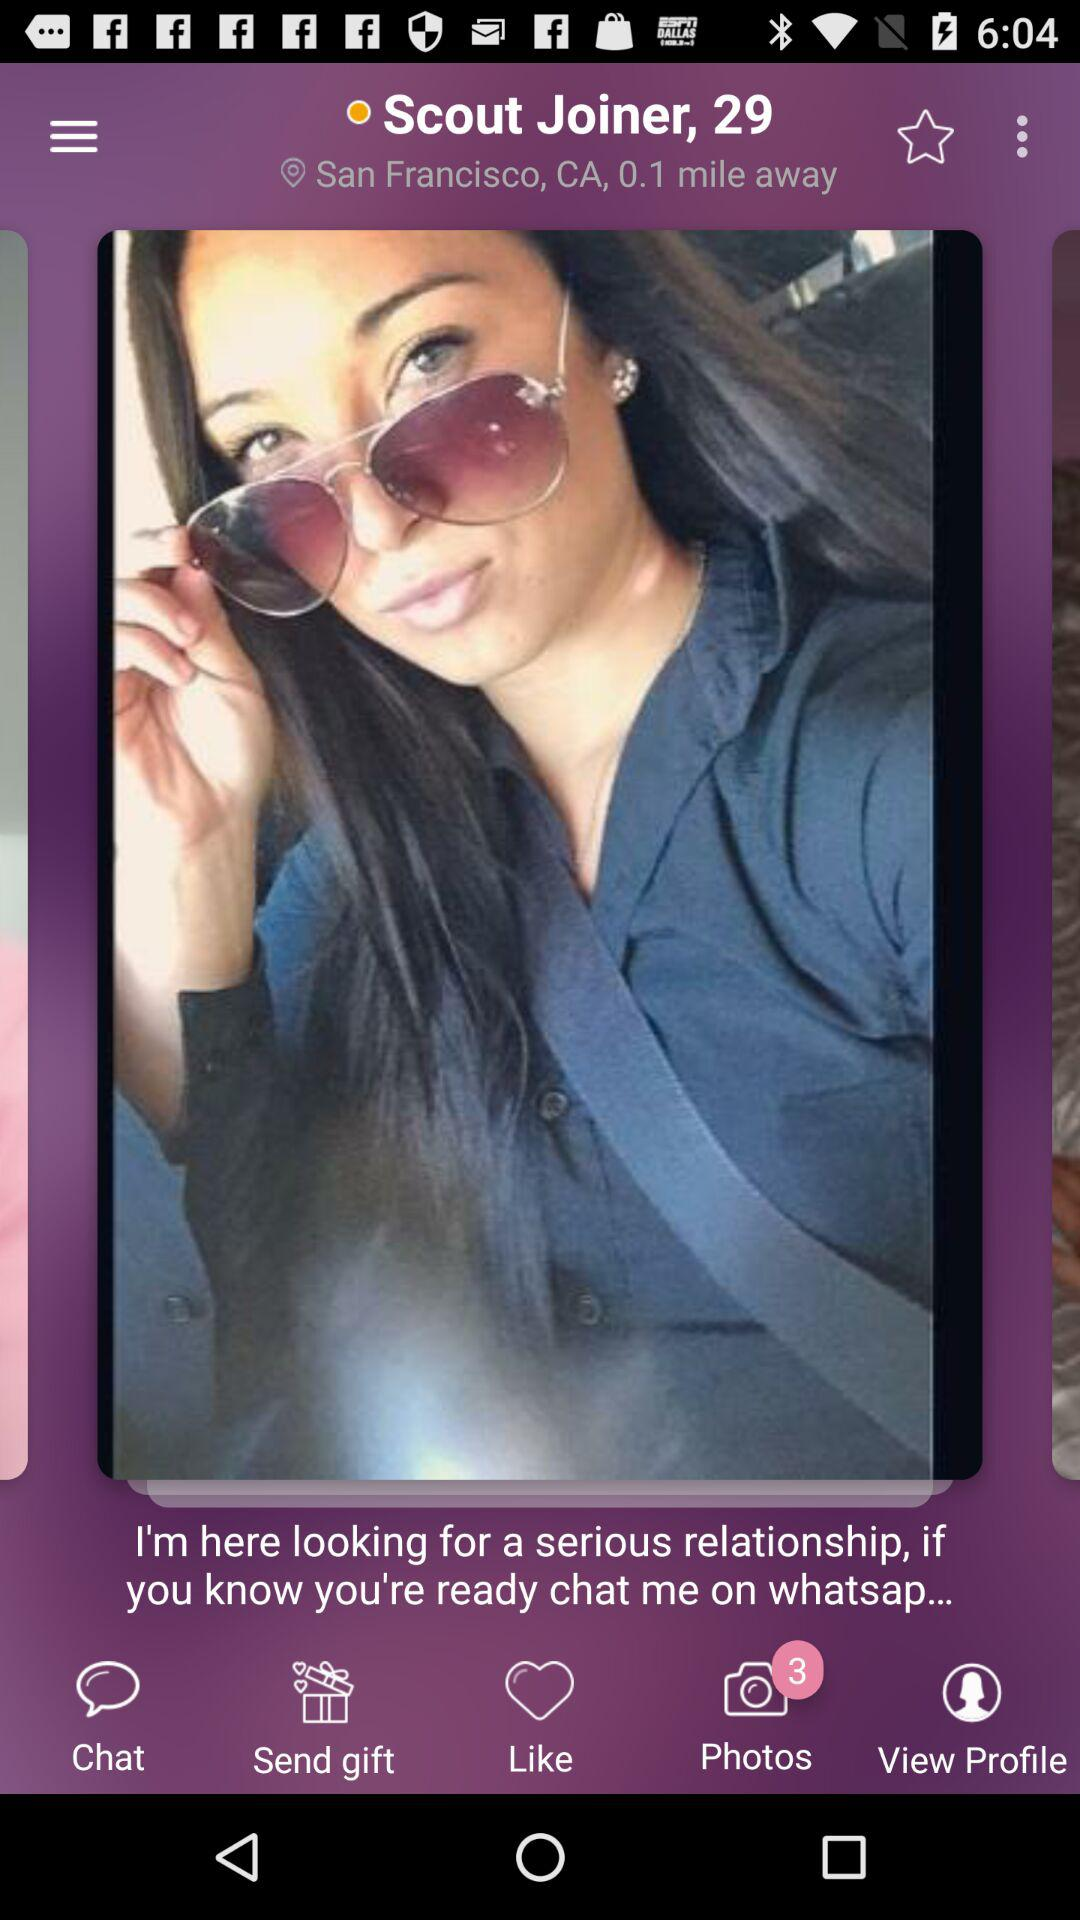What is the name of the person? The name of the person is Scout Joiner. 